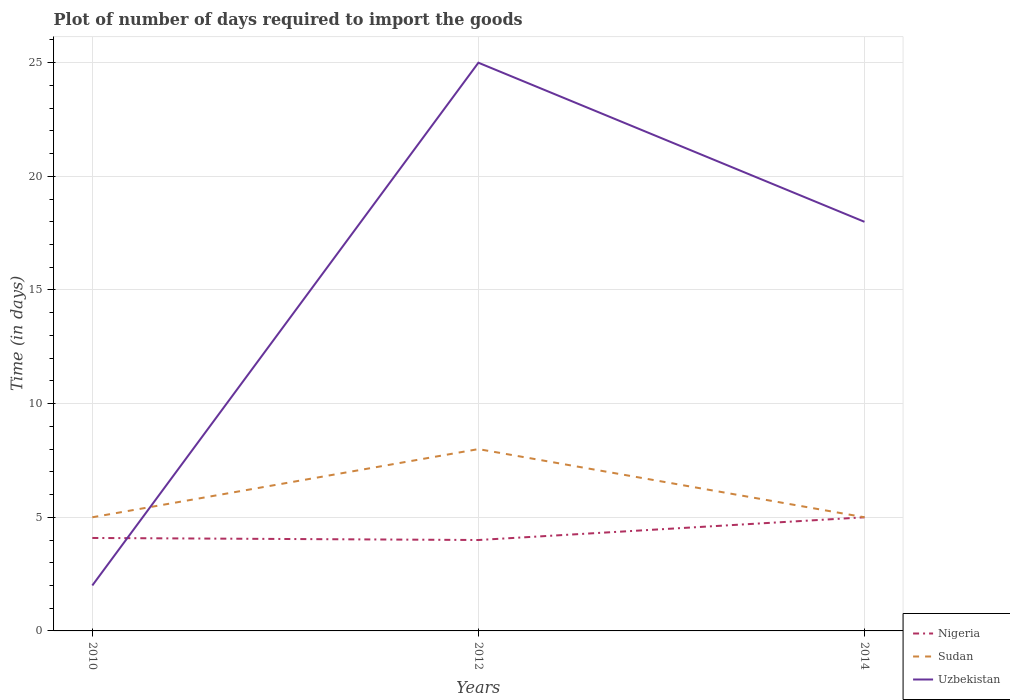Does the line corresponding to Nigeria intersect with the line corresponding to Uzbekistan?
Your answer should be compact. Yes. Is the number of lines equal to the number of legend labels?
Your answer should be compact. Yes. Across all years, what is the maximum time required to import goods in Nigeria?
Keep it short and to the point. 4. What is the difference between the highest and the second highest time required to import goods in Sudan?
Ensure brevity in your answer.  3. How many lines are there?
Ensure brevity in your answer.  3. How many years are there in the graph?
Offer a terse response. 3. What is the difference between two consecutive major ticks on the Y-axis?
Your answer should be very brief. 5. Are the values on the major ticks of Y-axis written in scientific E-notation?
Make the answer very short. No. Does the graph contain grids?
Make the answer very short. Yes. How are the legend labels stacked?
Offer a very short reply. Vertical. What is the title of the graph?
Provide a succinct answer. Plot of number of days required to import the goods. Does "Denmark" appear as one of the legend labels in the graph?
Your answer should be compact. No. What is the label or title of the X-axis?
Your answer should be very brief. Years. What is the label or title of the Y-axis?
Your response must be concise. Time (in days). What is the Time (in days) in Nigeria in 2010?
Ensure brevity in your answer.  4.09. What is the Time (in days) in Sudan in 2010?
Keep it short and to the point. 5. What is the Time (in days) of Uzbekistan in 2010?
Keep it short and to the point. 2. What is the Time (in days) in Nigeria in 2012?
Ensure brevity in your answer.  4. What is the Time (in days) in Sudan in 2012?
Your answer should be compact. 8. What is the Time (in days) of Uzbekistan in 2012?
Ensure brevity in your answer.  25. What is the Time (in days) in Nigeria in 2014?
Provide a short and direct response. 5. What is the total Time (in days) of Nigeria in the graph?
Keep it short and to the point. 13.09. What is the total Time (in days) in Sudan in the graph?
Provide a succinct answer. 18. What is the difference between the Time (in days) of Nigeria in 2010 and that in 2012?
Your response must be concise. 0.09. What is the difference between the Time (in days) in Nigeria in 2010 and that in 2014?
Your answer should be very brief. -0.91. What is the difference between the Time (in days) of Nigeria in 2012 and that in 2014?
Make the answer very short. -1. What is the difference between the Time (in days) in Sudan in 2012 and that in 2014?
Your answer should be very brief. 3. What is the difference between the Time (in days) of Nigeria in 2010 and the Time (in days) of Sudan in 2012?
Provide a succinct answer. -3.91. What is the difference between the Time (in days) in Nigeria in 2010 and the Time (in days) in Uzbekistan in 2012?
Your answer should be very brief. -20.91. What is the difference between the Time (in days) of Sudan in 2010 and the Time (in days) of Uzbekistan in 2012?
Offer a terse response. -20. What is the difference between the Time (in days) in Nigeria in 2010 and the Time (in days) in Sudan in 2014?
Provide a short and direct response. -0.91. What is the difference between the Time (in days) of Nigeria in 2010 and the Time (in days) of Uzbekistan in 2014?
Your answer should be very brief. -13.91. What is the difference between the Time (in days) in Nigeria in 2012 and the Time (in days) in Sudan in 2014?
Your response must be concise. -1. What is the difference between the Time (in days) of Sudan in 2012 and the Time (in days) of Uzbekistan in 2014?
Keep it short and to the point. -10. What is the average Time (in days) of Nigeria per year?
Your response must be concise. 4.36. What is the average Time (in days) of Sudan per year?
Give a very brief answer. 6. In the year 2010, what is the difference between the Time (in days) of Nigeria and Time (in days) of Sudan?
Keep it short and to the point. -0.91. In the year 2010, what is the difference between the Time (in days) in Nigeria and Time (in days) in Uzbekistan?
Your answer should be very brief. 2.09. What is the ratio of the Time (in days) of Nigeria in 2010 to that in 2012?
Ensure brevity in your answer.  1.02. What is the ratio of the Time (in days) of Nigeria in 2010 to that in 2014?
Provide a succinct answer. 0.82. What is the ratio of the Time (in days) in Uzbekistan in 2010 to that in 2014?
Your response must be concise. 0.11. What is the ratio of the Time (in days) of Nigeria in 2012 to that in 2014?
Your response must be concise. 0.8. What is the ratio of the Time (in days) in Uzbekistan in 2012 to that in 2014?
Your answer should be very brief. 1.39. What is the difference between the highest and the second highest Time (in days) of Nigeria?
Ensure brevity in your answer.  0.91. What is the difference between the highest and the second highest Time (in days) in Sudan?
Offer a terse response. 3. What is the difference between the highest and the second highest Time (in days) of Uzbekistan?
Ensure brevity in your answer.  7. What is the difference between the highest and the lowest Time (in days) in Uzbekistan?
Make the answer very short. 23. 